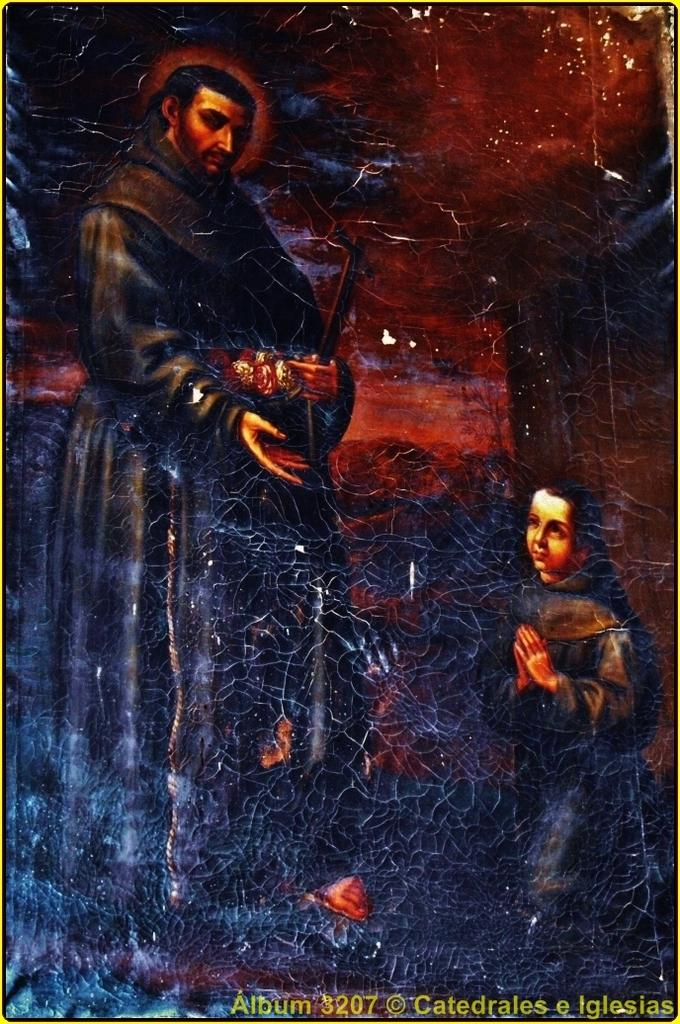<image>
Write a terse but informative summary of the picture. A religious picture that is part of album 3207. 